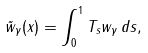Convert formula to latex. <formula><loc_0><loc_0><loc_500><loc_500>\tilde { w } _ { \gamma } ( x ) = \int _ { 0 } ^ { 1 } T _ { s } w _ { \gamma } \, d s ,</formula> 